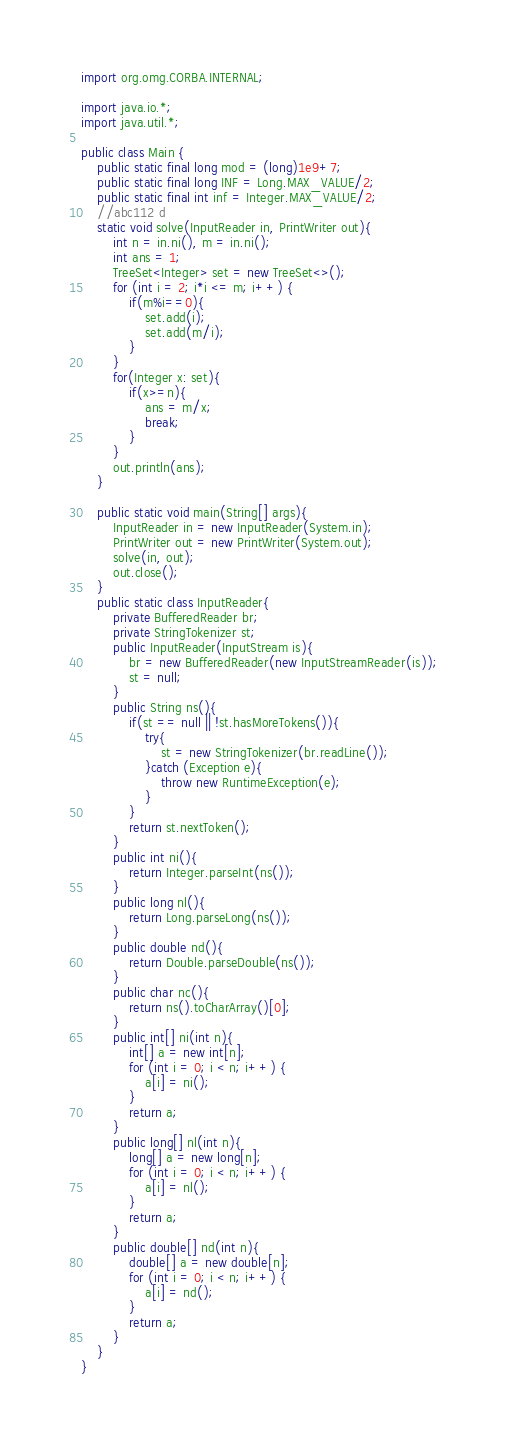<code> <loc_0><loc_0><loc_500><loc_500><_Java_>import org.omg.CORBA.INTERNAL;

import java.io.*;
import java.util.*;

public class Main {
    public static final long mod = (long)1e9+7;
    public static final long INF = Long.MAX_VALUE/2;
    public static final int inf = Integer.MAX_VALUE/2;
    //abc112 d
    static void solve(InputReader in, PrintWriter out){
        int n = in.ni(), m = in.ni();
        int ans = 1;
        TreeSet<Integer> set = new TreeSet<>();
        for (int i = 2; i*i <= m; i++) {
            if(m%i==0){
                set.add(i);
                set.add(m/i);
            }
        }
        for(Integer x: set){
            if(x>=n){
                ans = m/x;
                break;
            }
        }
        out.println(ans);
    }

    public static void main(String[] args){
        InputReader in = new InputReader(System.in);
        PrintWriter out = new PrintWriter(System.out);
        solve(in, out);
        out.close();
    }
    public static class InputReader{
        private BufferedReader br;
        private StringTokenizer st;
        public InputReader(InputStream is){
            br = new BufferedReader(new InputStreamReader(is));
            st = null;
        }
        public String ns(){
            if(st == null || !st.hasMoreTokens()){
                try{
                    st = new StringTokenizer(br.readLine());
                }catch (Exception e){
                    throw new RuntimeException(e);
                }
            }
            return st.nextToken();
        }
        public int ni(){
            return Integer.parseInt(ns());
        }
        public long nl(){
            return Long.parseLong(ns());
        }
        public double nd(){
            return Double.parseDouble(ns());
        }
        public char nc(){
            return ns().toCharArray()[0];
        }
        public int[] ni(int n){
            int[] a = new int[n];
            for (int i = 0; i < n; i++) {
                a[i] = ni();
            }
            return a;
        }
        public long[] nl(int n){
            long[] a = new long[n];
            for (int i = 0; i < n; i++) {
                a[i] = nl();
            }
            return a;
        }
        public double[] nd(int n){
            double[] a = new double[n];
            for (int i = 0; i < n; i++) {
                a[i] = nd();
            }
            return a;
        }
    }
}</code> 